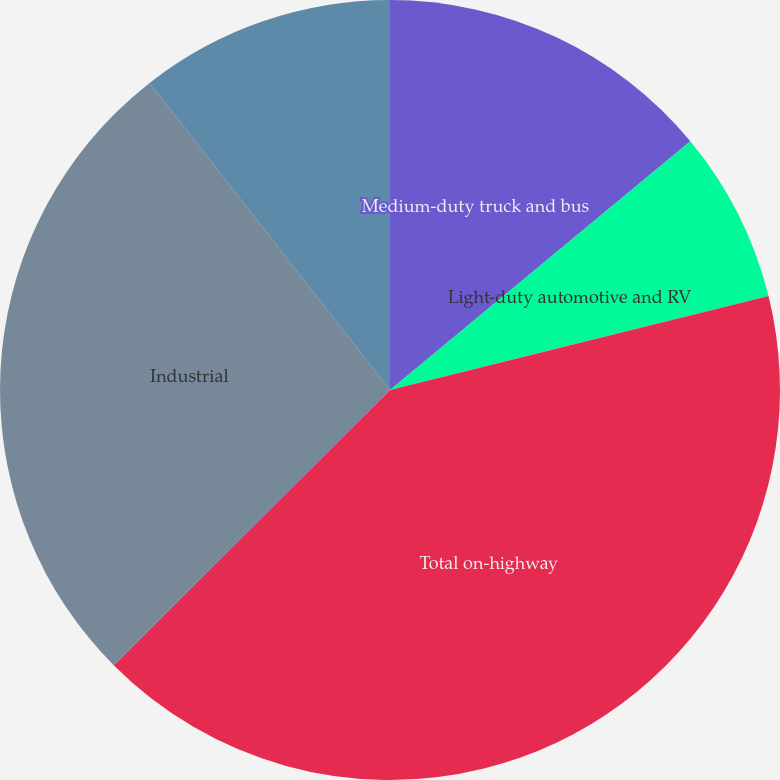Convert chart to OTSL. <chart><loc_0><loc_0><loc_500><loc_500><pie_chart><fcel>Medium-duty truck and bus<fcel>Light-duty automotive and RV<fcel>Total on-highway<fcel>Industrial<fcel>Stationary power<nl><fcel>13.99%<fcel>7.14%<fcel>41.4%<fcel>26.9%<fcel>10.57%<nl></chart> 